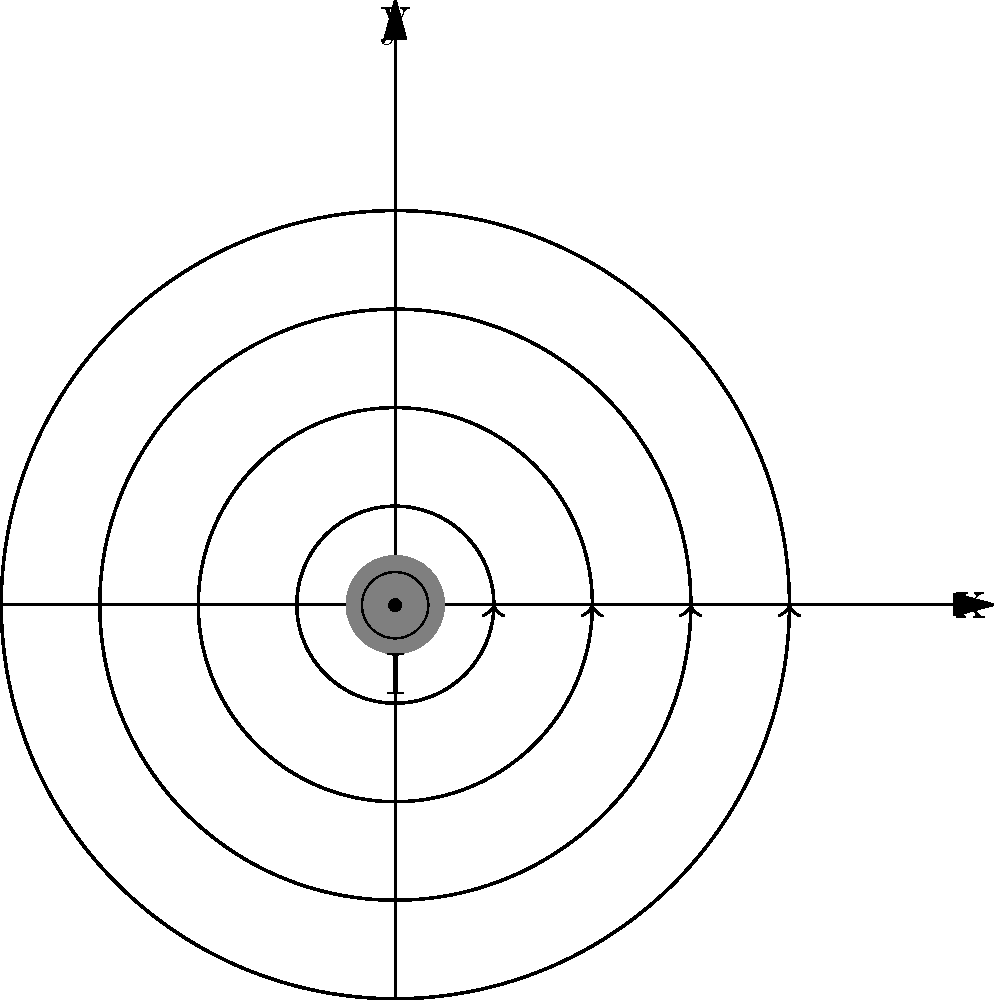As a team leader fostering collaboration, you're explaining the concept of magnetic fields to a diverse group. In the diagram, a current-carrying wire is shown in cross-section with its magnetic field lines. If the current is flowing out of the page (represented by $\odot$), what is the direction of the magnetic field at point P (x > 0, y > 0)? To determine the direction of the magnetic field at point P, we'll use a step-by-step approach that incorporates both physics principles and leadership insights:

1. Recall the right-hand rule: When we wrap our right hand around the wire with our thumb pointing in the direction of the current, our fingers indicate the direction of the magnetic field lines.

2. In this case, the current is flowing out of the page (represented by $\odot$), so our thumb would be pointing towards us.

3. As we wrap our fingers around the wire, we notice that they curl in a counterclockwise direction when viewed from above.

4. Looking at the diagram, we can see that the magnetic field lines are indeed circling counterclockwise around the wire.

5. At any point on a magnetic field line, the direction of the magnetic field is tangent to the circle at that point.

6. For point P in the first quadrant (x > 0, y > 0), the tangent to the circular field line would be pointing downward and to the left.

7. In vector notation, this direction would be described as having negative components in both the x and y directions.

As a leader, it's important to explain this concept clearly and encourage team members to visualize it. You might ask seasoned employees to share their experiences or analogies that have helped them understand this concept in the past, fostering a collaborative learning environment.
Answer: Downward and to the left (in the -x and -y directions) 